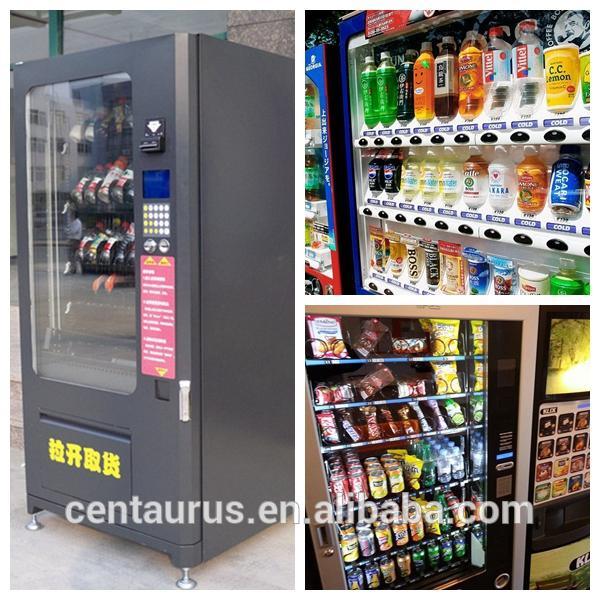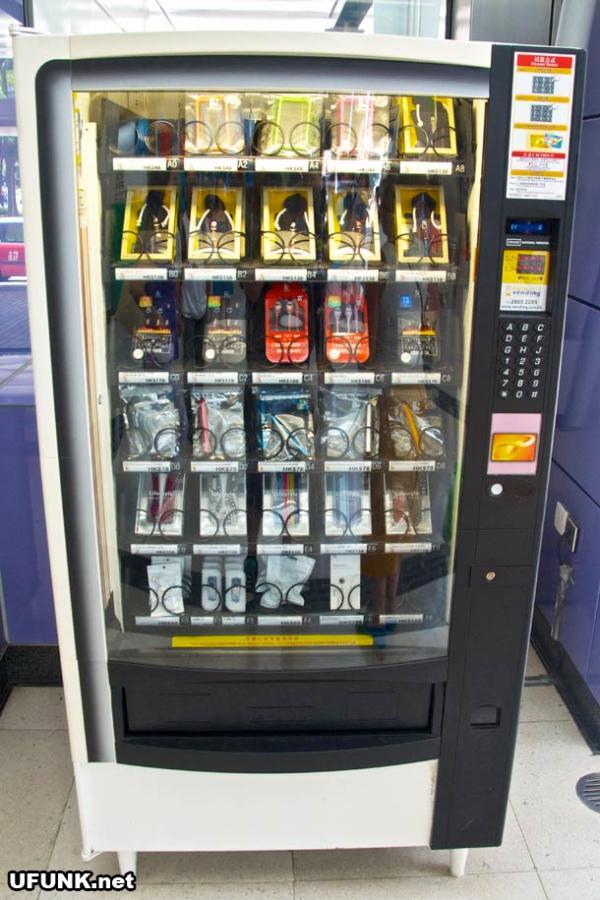The first image is the image on the left, the second image is the image on the right. Evaluate the accuracy of this statement regarding the images: "Real oranges are visible in the top half of all the vending machines, which also feature orange as a major part of their color schemes.". Is it true? Answer yes or no. No. The first image is the image on the left, the second image is the image on the right. For the images displayed, is the sentence "A human is standing next to a vending machine in one of the images." factually correct? Answer yes or no. No. 